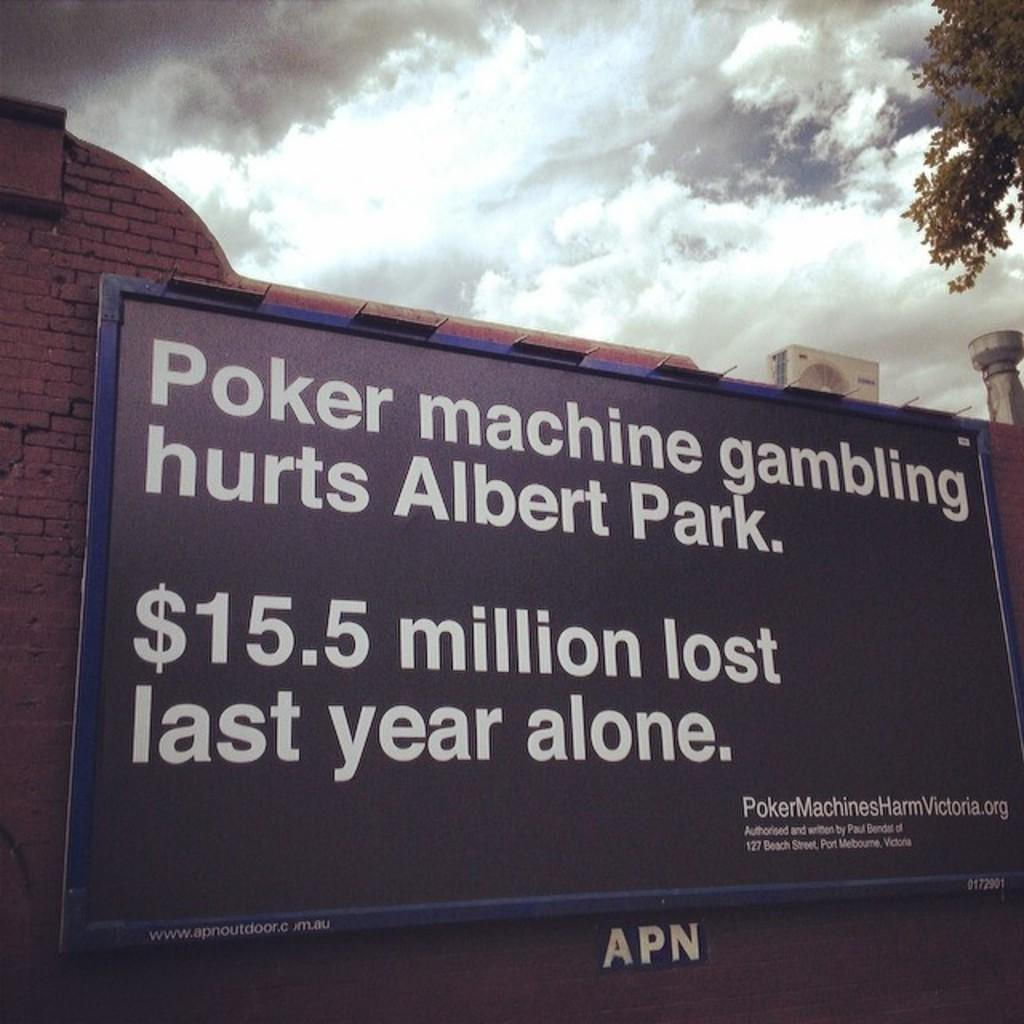<image>
Provide a brief description of the given image. large sign on a brick wall stating that albert park lost $15.5 million to poker machine gambling last year 